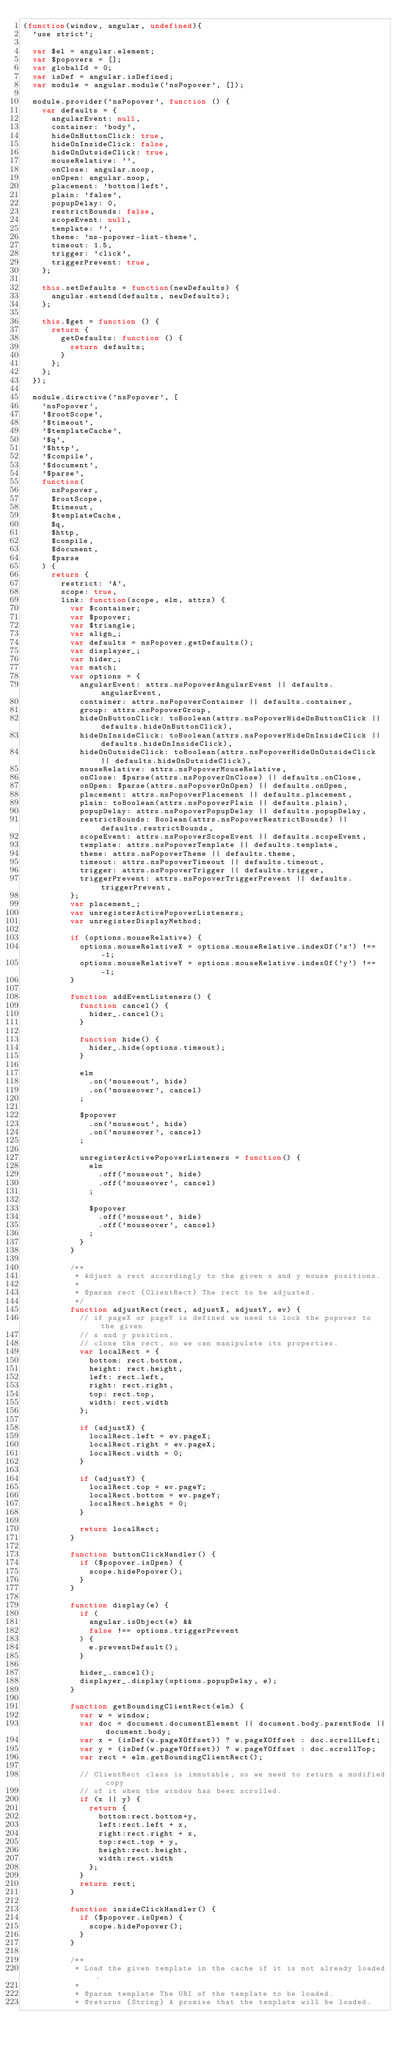<code> <loc_0><loc_0><loc_500><loc_500><_JavaScript_>(function(window, angular, undefined){
  'use strict';

  var $el = angular.element;
  var $popovers = [];
  var globalId = 0;
  var isDef = angular.isDefined;
  var module = angular.module('nsPopover', []);

  module.provider('nsPopover', function () {
    var defaults = {
      angularEvent: null,
      container: 'body',
      hideOnButtonClick: true,
      hideOnInsideClick: false,
      hideOnOutsideClick: true,
      mouseRelative: '',
      onClose: angular.noop,
      onOpen: angular.noop,
      placement: 'bottom|left',
      plain: 'false',
      popupDelay: 0,
      restrictBounds: false,
      scopeEvent: null,
      template: '',
      theme: 'ns-popover-list-theme',
      timeout: 1.5,
      trigger: 'click',
      triggerPrevent: true,
    };

    this.setDefaults = function(newDefaults) {
      angular.extend(defaults, newDefaults);
    };

    this.$get = function () {
      return {
        getDefaults: function () {
          return defaults;
        }
      };
    };
  });

  module.directive('nsPopover', [
    'nsPopover',
    '$rootScope',
    '$timeout',
    '$templateCache',
    '$q',
    '$http',
    '$compile',
    '$document',
    '$parse',
    function(
      nsPopover,
      $rootScope,
      $timeout,
      $templateCache,
      $q,
      $http,
      $compile,
      $document,
      $parse
    ) {
      return {
        restrict: 'A',
        scope: true,
        link: function(scope, elm, attrs) {
          var $container;
          var $popover;
          var $triangle;
          var align_;
          var defaults = nsPopover.getDefaults();
          var displayer_;
          var hider_;
          var match;
          var options = {
            angularEvent: attrs.nsPopoverAngularEvent || defaults.angularEvent,
            container: attrs.nsPopoverContainer || defaults.container,
            group: attrs.nsPopoverGroup,
            hideOnButtonClick: toBoolean(attrs.nsPopoverHideOnButtonClick || defaults.hideOnButtonClick),
            hideOnInsideClick: toBoolean(attrs.nsPopoverHideOnInsideClick || defaults.hideOnInsideClick),
            hideOnOutsideClick: toBoolean(attrs.nsPopoverHideOnOutsideClick || defaults.hideOnOutsideClick),
            mouseRelative: attrs.nsPopoverMouseRelative,
            onClose: $parse(attrs.nsPopoverOnClose) || defaults.onClose,
            onOpen: $parse(attrs.nsPopoverOnOpen) || defaults.onOpen,
            placement: attrs.nsPopoverPlacement || defaults.placement,
            plain: toBoolean(attrs.nsPopoverPlain || defaults.plain),
            popupDelay: attrs.nsPopoverPopupDelay || defaults.popupDelay,
            restrictBounds: Boolean(attrs.nsPopoverRestrictBounds) || defaults.restrictBounds,
            scopeEvent: attrs.nsPopoverScopeEvent || defaults.scopeEvent,
            template: attrs.nsPopoverTemplate || defaults.template,
            theme: attrs.nsPopoverTheme || defaults.theme,
            timeout: attrs.nsPopoverTimeout || defaults.timeout,
            trigger: attrs.nsPopoverTrigger || defaults.trigger,
            triggerPrevent: attrs.nsPopoverTriggerPrevent || defaults.triggerPrevent,
          };
          var placement_;
          var unregisterActivePopoverListeners;
          var unregisterDisplayMethod;

          if (options.mouseRelative) {
            options.mouseRelativeX = options.mouseRelative.indexOf('x') !== -1;
            options.mouseRelativeY = options.mouseRelative.indexOf('y') !== -1;
          }

          function addEventListeners() {
            function cancel() {
              hider_.cancel();
            }

            function hide() {
              hider_.hide(options.timeout);
            }

            elm
              .on('mouseout', hide)
              .on('mouseover', cancel)
            ;

            $popover
              .on('mouseout', hide)
              .on('mouseover', cancel)
            ;

            unregisterActivePopoverListeners = function() {
              elm
                .off('mouseout', hide)
                .off('mouseover', cancel)
              ;

              $popover
                .off('mouseout', hide)
                .off('mouseover', cancel)
              ;
            }
          }

          /**
           * Adjust a rect accordingly to the given x and y mouse positions.
           *
           * @param rect {ClientRect} The rect to be adjusted.
           */
          function adjustRect(rect, adjustX, adjustY, ev) {
            // if pageX or pageY is defined we need to lock the popover to the given
            // x and y position.
            // clone the rect, so we can manipulate its properties.
            var localRect = {
              bottom: rect.bottom,
              height: rect.height,
              left: rect.left,
              right: rect.right,
              top: rect.top,
              width: rect.width
            };

            if (adjustX) {
              localRect.left = ev.pageX;
              localRect.right = ev.pageX;
              localRect.width = 0;
            }

            if (adjustY) {
              localRect.top = ev.pageY;
              localRect.bottom = ev.pageY;
              localRect.height = 0;
            }

            return localRect;
          }

          function buttonClickHandler() {
            if ($popover.isOpen) {
              scope.hidePopover();
            }
          }

          function display(e) {
            if (
              angular.isObject(e) &&
              false !== options.triggerPrevent
            ) {
              e.preventDefault();
            }

            hider_.cancel();
            displayer_.display(options.popupDelay, e);
          }

          function getBoundingClientRect(elm) {
            var w = window;
            var doc = document.documentElement || document.body.parentNode || document.body;
            var x = (isDef(w.pageXOffset)) ? w.pageXOffset : doc.scrollLeft;
            var y = (isDef(w.pageYOffset)) ? w.pageYOffset : doc.scrollTop;
            var rect = elm.getBoundingClientRect();

            // ClientRect class is immutable, so we need to return a modified copy
            // of it when the window has been scrolled.
            if (x || y) {
              return {
                bottom:rect.bottom+y,
                left:rect.left + x,
                right:rect.right + x,
                top:rect.top + y,
                height:rect.height,
                width:rect.width
              };
            }
            return rect;
          }

          function insideClickHandler() {
            if ($popover.isOpen) {
              scope.hidePopover();
            }
          }

          /**
           * Load the given template in the cache if it is not already loaded.
           *
           * @param template The URI of the template to be loaded.
           * @returns {String} A promise that the template will be loaded.</code> 